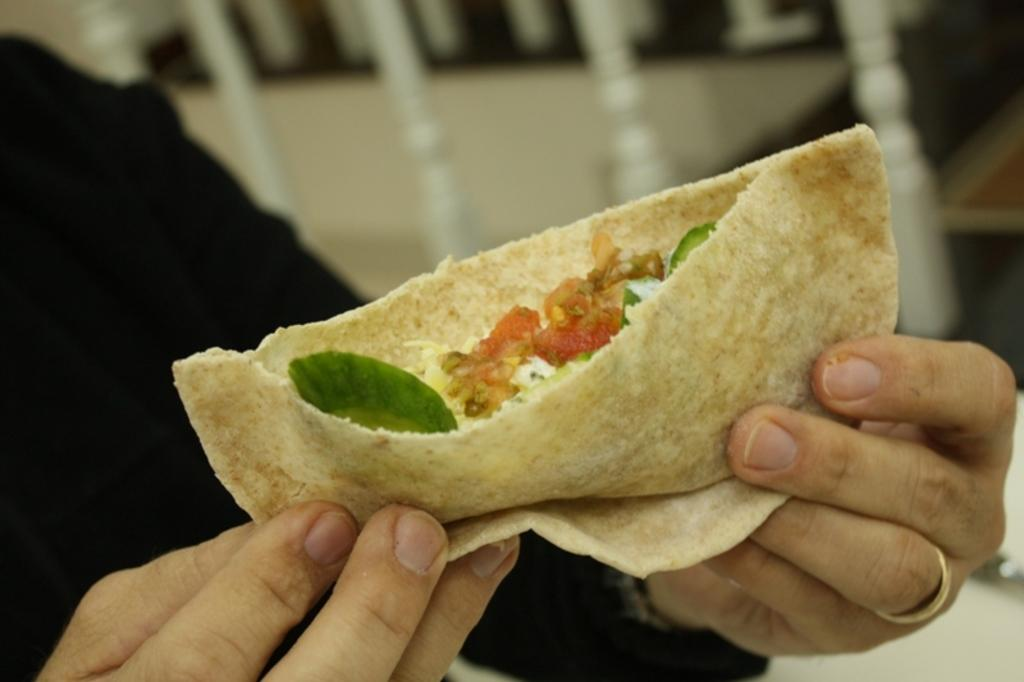What is the primary subject in the image? There is a human in the image. What is the human doing in the image? The human is holding food in their hand. What type of structure can be seen in the background of the image? There is a fence visible in the image. What type of berry is the human eating in the image? There is no berry present in the image; the human is holding food, but it is not specified as a berry. 